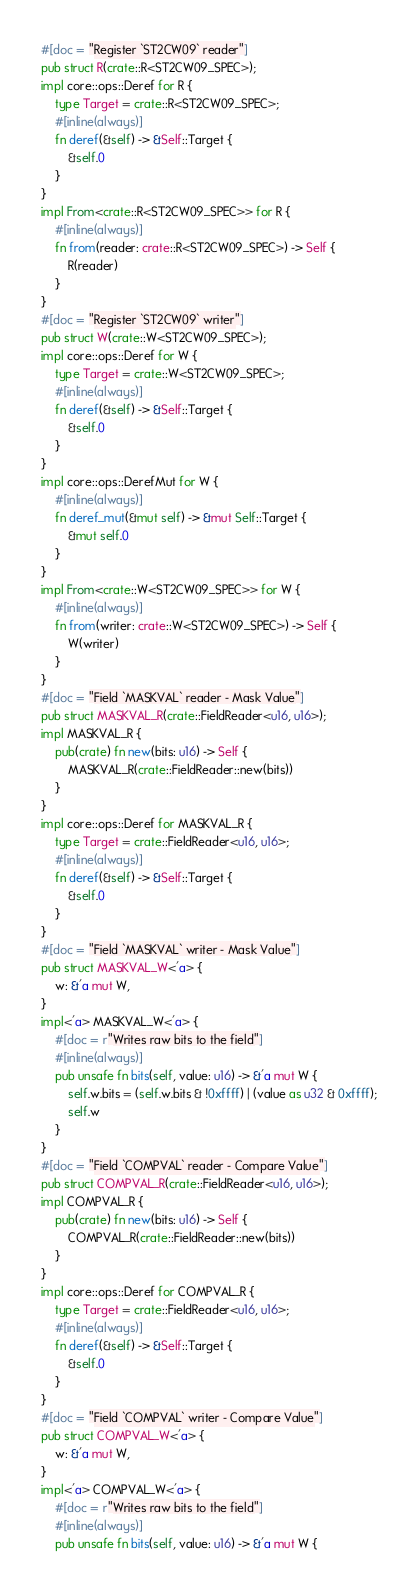<code> <loc_0><loc_0><loc_500><loc_500><_Rust_>#[doc = "Register `ST2CW09` reader"]
pub struct R(crate::R<ST2CW09_SPEC>);
impl core::ops::Deref for R {
    type Target = crate::R<ST2CW09_SPEC>;
    #[inline(always)]
    fn deref(&self) -> &Self::Target {
        &self.0
    }
}
impl From<crate::R<ST2CW09_SPEC>> for R {
    #[inline(always)]
    fn from(reader: crate::R<ST2CW09_SPEC>) -> Self {
        R(reader)
    }
}
#[doc = "Register `ST2CW09` writer"]
pub struct W(crate::W<ST2CW09_SPEC>);
impl core::ops::Deref for W {
    type Target = crate::W<ST2CW09_SPEC>;
    #[inline(always)]
    fn deref(&self) -> &Self::Target {
        &self.0
    }
}
impl core::ops::DerefMut for W {
    #[inline(always)]
    fn deref_mut(&mut self) -> &mut Self::Target {
        &mut self.0
    }
}
impl From<crate::W<ST2CW09_SPEC>> for W {
    #[inline(always)]
    fn from(writer: crate::W<ST2CW09_SPEC>) -> Self {
        W(writer)
    }
}
#[doc = "Field `MASKVAL` reader - Mask Value"]
pub struct MASKVAL_R(crate::FieldReader<u16, u16>);
impl MASKVAL_R {
    pub(crate) fn new(bits: u16) -> Self {
        MASKVAL_R(crate::FieldReader::new(bits))
    }
}
impl core::ops::Deref for MASKVAL_R {
    type Target = crate::FieldReader<u16, u16>;
    #[inline(always)]
    fn deref(&self) -> &Self::Target {
        &self.0
    }
}
#[doc = "Field `MASKVAL` writer - Mask Value"]
pub struct MASKVAL_W<'a> {
    w: &'a mut W,
}
impl<'a> MASKVAL_W<'a> {
    #[doc = r"Writes raw bits to the field"]
    #[inline(always)]
    pub unsafe fn bits(self, value: u16) -> &'a mut W {
        self.w.bits = (self.w.bits & !0xffff) | (value as u32 & 0xffff);
        self.w
    }
}
#[doc = "Field `COMPVAL` reader - Compare Value"]
pub struct COMPVAL_R(crate::FieldReader<u16, u16>);
impl COMPVAL_R {
    pub(crate) fn new(bits: u16) -> Self {
        COMPVAL_R(crate::FieldReader::new(bits))
    }
}
impl core::ops::Deref for COMPVAL_R {
    type Target = crate::FieldReader<u16, u16>;
    #[inline(always)]
    fn deref(&self) -> &Self::Target {
        &self.0
    }
}
#[doc = "Field `COMPVAL` writer - Compare Value"]
pub struct COMPVAL_W<'a> {
    w: &'a mut W,
}
impl<'a> COMPVAL_W<'a> {
    #[doc = r"Writes raw bits to the field"]
    #[inline(always)]
    pub unsafe fn bits(self, value: u16) -> &'a mut W {</code> 